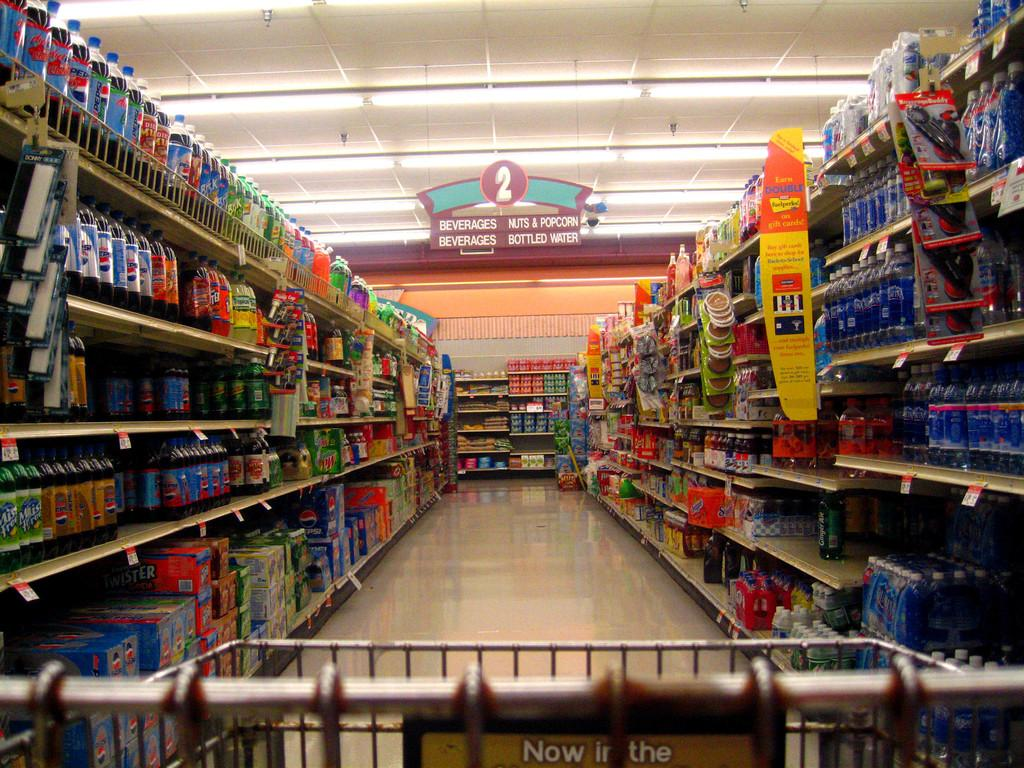<image>
Share a concise interpretation of the image provided. Store aisle for beverages as well as nuts and popcorn. 